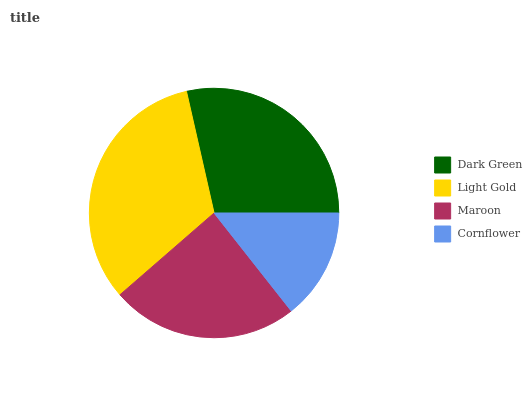Is Cornflower the minimum?
Answer yes or no. Yes. Is Light Gold the maximum?
Answer yes or no. Yes. Is Maroon the minimum?
Answer yes or no. No. Is Maroon the maximum?
Answer yes or no. No. Is Light Gold greater than Maroon?
Answer yes or no. Yes. Is Maroon less than Light Gold?
Answer yes or no. Yes. Is Maroon greater than Light Gold?
Answer yes or no. No. Is Light Gold less than Maroon?
Answer yes or no. No. Is Dark Green the high median?
Answer yes or no. Yes. Is Maroon the low median?
Answer yes or no. Yes. Is Cornflower the high median?
Answer yes or no. No. Is Dark Green the low median?
Answer yes or no. No. 